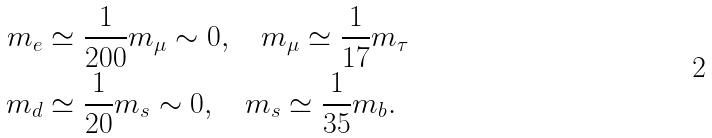Convert formula to latex. <formula><loc_0><loc_0><loc_500><loc_500>m _ { e } & \simeq \frac { 1 } { 2 0 0 } m _ { \mu } \sim 0 , \quad m _ { \mu } \simeq \frac { 1 } { 1 7 } m _ { \tau } \\ m _ { d } & \simeq \frac { 1 } { 2 0 } m _ { s } \sim 0 , \quad m _ { s } \simeq \frac { 1 } { 3 5 } m _ { b } .</formula> 